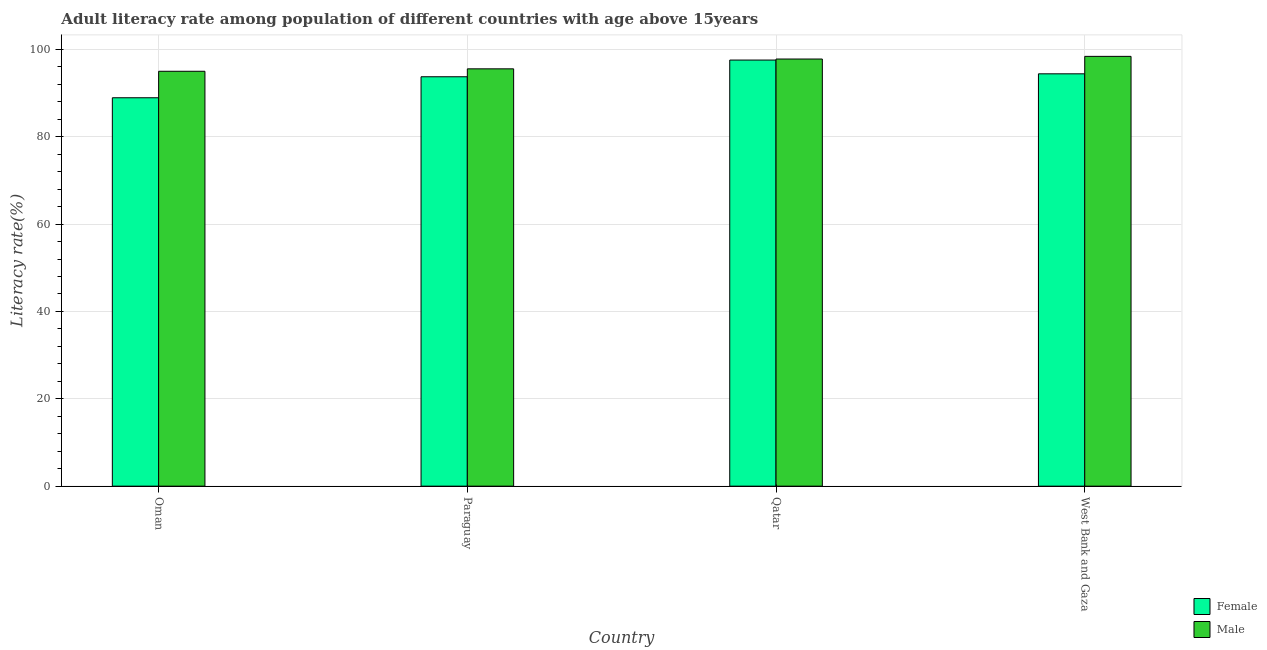Are the number of bars on each tick of the X-axis equal?
Make the answer very short. Yes. How many bars are there on the 3rd tick from the right?
Make the answer very short. 2. What is the label of the 2nd group of bars from the left?
Your response must be concise. Paraguay. In how many cases, is the number of bars for a given country not equal to the number of legend labels?
Provide a succinct answer. 0. What is the male adult literacy rate in Qatar?
Your answer should be very brief. 97.79. Across all countries, what is the maximum female adult literacy rate?
Provide a succinct answer. 97.56. Across all countries, what is the minimum female adult literacy rate?
Provide a succinct answer. 88.93. In which country was the female adult literacy rate maximum?
Your answer should be compact. Qatar. In which country was the male adult literacy rate minimum?
Provide a short and direct response. Oman. What is the total female adult literacy rate in the graph?
Provide a succinct answer. 374.63. What is the difference between the female adult literacy rate in Paraguay and that in Qatar?
Offer a terse response. -3.82. What is the difference between the male adult literacy rate in West Bank and Gaza and the female adult literacy rate in Oman?
Your answer should be very brief. 9.48. What is the average male adult literacy rate per country?
Keep it short and to the point. 96.68. What is the difference between the male adult literacy rate and female adult literacy rate in Paraguay?
Provide a succinct answer. 1.81. What is the ratio of the female adult literacy rate in Oman to that in West Bank and Gaza?
Your answer should be very brief. 0.94. Is the female adult literacy rate in Oman less than that in Qatar?
Offer a very short reply. Yes. Is the difference between the female adult literacy rate in Oman and West Bank and Gaza greater than the difference between the male adult literacy rate in Oman and West Bank and Gaza?
Make the answer very short. No. What is the difference between the highest and the second highest male adult literacy rate?
Offer a very short reply. 0.61. What is the difference between the highest and the lowest male adult literacy rate?
Your answer should be compact. 3.41. In how many countries, is the female adult literacy rate greater than the average female adult literacy rate taken over all countries?
Give a very brief answer. 3. How many bars are there?
Make the answer very short. 8. Are all the bars in the graph horizontal?
Offer a very short reply. No. How many countries are there in the graph?
Your answer should be very brief. 4. Are the values on the major ticks of Y-axis written in scientific E-notation?
Offer a very short reply. No. Does the graph contain any zero values?
Provide a succinct answer. No. Does the graph contain grids?
Provide a short and direct response. Yes. Where does the legend appear in the graph?
Offer a very short reply. Bottom right. How many legend labels are there?
Give a very brief answer. 2. How are the legend labels stacked?
Your answer should be compact. Vertical. What is the title of the graph?
Provide a succinct answer. Adult literacy rate among population of different countries with age above 15years. Does "Fertility rate" appear as one of the legend labels in the graph?
Keep it short and to the point. No. What is the label or title of the X-axis?
Make the answer very short. Country. What is the label or title of the Y-axis?
Make the answer very short. Literacy rate(%). What is the Literacy rate(%) in Female in Oman?
Your response must be concise. 88.93. What is the Literacy rate(%) of Male in Oman?
Your answer should be very brief. 94.99. What is the Literacy rate(%) of Female in Paraguay?
Provide a succinct answer. 93.73. What is the Literacy rate(%) in Male in Paraguay?
Make the answer very short. 95.55. What is the Literacy rate(%) in Female in Qatar?
Offer a very short reply. 97.56. What is the Literacy rate(%) in Male in Qatar?
Your response must be concise. 97.79. What is the Literacy rate(%) in Female in West Bank and Gaza?
Offer a terse response. 94.41. What is the Literacy rate(%) in Male in West Bank and Gaza?
Provide a short and direct response. 98.4. Across all countries, what is the maximum Literacy rate(%) in Female?
Your response must be concise. 97.56. Across all countries, what is the maximum Literacy rate(%) of Male?
Your answer should be compact. 98.4. Across all countries, what is the minimum Literacy rate(%) of Female?
Offer a very short reply. 88.93. Across all countries, what is the minimum Literacy rate(%) of Male?
Provide a short and direct response. 94.99. What is the total Literacy rate(%) in Female in the graph?
Offer a terse response. 374.63. What is the total Literacy rate(%) in Male in the graph?
Offer a very short reply. 386.73. What is the difference between the Literacy rate(%) of Female in Oman and that in Paraguay?
Provide a succinct answer. -4.81. What is the difference between the Literacy rate(%) of Male in Oman and that in Paraguay?
Give a very brief answer. -0.56. What is the difference between the Literacy rate(%) in Female in Oman and that in Qatar?
Ensure brevity in your answer.  -8.63. What is the difference between the Literacy rate(%) of Male in Oman and that in Qatar?
Offer a terse response. -2.8. What is the difference between the Literacy rate(%) of Female in Oman and that in West Bank and Gaza?
Offer a terse response. -5.48. What is the difference between the Literacy rate(%) of Male in Oman and that in West Bank and Gaza?
Keep it short and to the point. -3.41. What is the difference between the Literacy rate(%) of Female in Paraguay and that in Qatar?
Your answer should be very brief. -3.82. What is the difference between the Literacy rate(%) in Male in Paraguay and that in Qatar?
Give a very brief answer. -2.25. What is the difference between the Literacy rate(%) of Female in Paraguay and that in West Bank and Gaza?
Ensure brevity in your answer.  -0.67. What is the difference between the Literacy rate(%) of Male in Paraguay and that in West Bank and Gaza?
Provide a short and direct response. -2.86. What is the difference between the Literacy rate(%) of Female in Qatar and that in West Bank and Gaza?
Ensure brevity in your answer.  3.15. What is the difference between the Literacy rate(%) of Male in Qatar and that in West Bank and Gaza?
Make the answer very short. -0.61. What is the difference between the Literacy rate(%) in Female in Oman and the Literacy rate(%) in Male in Paraguay?
Provide a succinct answer. -6.62. What is the difference between the Literacy rate(%) of Female in Oman and the Literacy rate(%) of Male in Qatar?
Your answer should be compact. -8.87. What is the difference between the Literacy rate(%) of Female in Oman and the Literacy rate(%) of Male in West Bank and Gaza?
Make the answer very short. -9.48. What is the difference between the Literacy rate(%) in Female in Paraguay and the Literacy rate(%) in Male in Qatar?
Give a very brief answer. -4.06. What is the difference between the Literacy rate(%) of Female in Paraguay and the Literacy rate(%) of Male in West Bank and Gaza?
Provide a short and direct response. -4.67. What is the difference between the Literacy rate(%) in Female in Qatar and the Literacy rate(%) in Male in West Bank and Gaza?
Make the answer very short. -0.84. What is the average Literacy rate(%) in Female per country?
Provide a succinct answer. 93.66. What is the average Literacy rate(%) of Male per country?
Your response must be concise. 96.68. What is the difference between the Literacy rate(%) in Female and Literacy rate(%) in Male in Oman?
Make the answer very short. -6.06. What is the difference between the Literacy rate(%) in Female and Literacy rate(%) in Male in Paraguay?
Make the answer very short. -1.81. What is the difference between the Literacy rate(%) in Female and Literacy rate(%) in Male in Qatar?
Your answer should be very brief. -0.24. What is the difference between the Literacy rate(%) of Female and Literacy rate(%) of Male in West Bank and Gaza?
Your answer should be compact. -4. What is the ratio of the Literacy rate(%) of Female in Oman to that in Paraguay?
Keep it short and to the point. 0.95. What is the ratio of the Literacy rate(%) of Female in Oman to that in Qatar?
Your response must be concise. 0.91. What is the ratio of the Literacy rate(%) of Male in Oman to that in Qatar?
Ensure brevity in your answer.  0.97. What is the ratio of the Literacy rate(%) in Female in Oman to that in West Bank and Gaza?
Offer a terse response. 0.94. What is the ratio of the Literacy rate(%) in Male in Oman to that in West Bank and Gaza?
Provide a succinct answer. 0.97. What is the ratio of the Literacy rate(%) of Female in Paraguay to that in Qatar?
Offer a terse response. 0.96. What is the ratio of the Literacy rate(%) of Male in Paraguay to that in Qatar?
Make the answer very short. 0.98. What is the ratio of the Literacy rate(%) in Female in Paraguay to that in West Bank and Gaza?
Your answer should be compact. 0.99. What is the ratio of the Literacy rate(%) in Male in Paraguay to that in West Bank and Gaza?
Make the answer very short. 0.97. What is the ratio of the Literacy rate(%) in Female in Qatar to that in West Bank and Gaza?
Offer a very short reply. 1.03. What is the ratio of the Literacy rate(%) in Male in Qatar to that in West Bank and Gaza?
Your response must be concise. 0.99. What is the difference between the highest and the second highest Literacy rate(%) in Female?
Make the answer very short. 3.15. What is the difference between the highest and the second highest Literacy rate(%) in Male?
Give a very brief answer. 0.61. What is the difference between the highest and the lowest Literacy rate(%) in Female?
Offer a very short reply. 8.63. What is the difference between the highest and the lowest Literacy rate(%) of Male?
Ensure brevity in your answer.  3.41. 